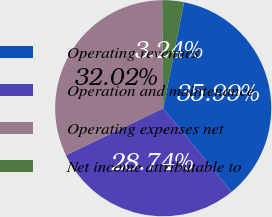Convert chart to OTSL. <chart><loc_0><loc_0><loc_500><loc_500><pie_chart><fcel>Operating revenues<fcel>Operation and maintenance<fcel>Operating expenses net<fcel>Net income attributable to<nl><fcel>35.99%<fcel>28.74%<fcel>32.02%<fcel>3.24%<nl></chart> 